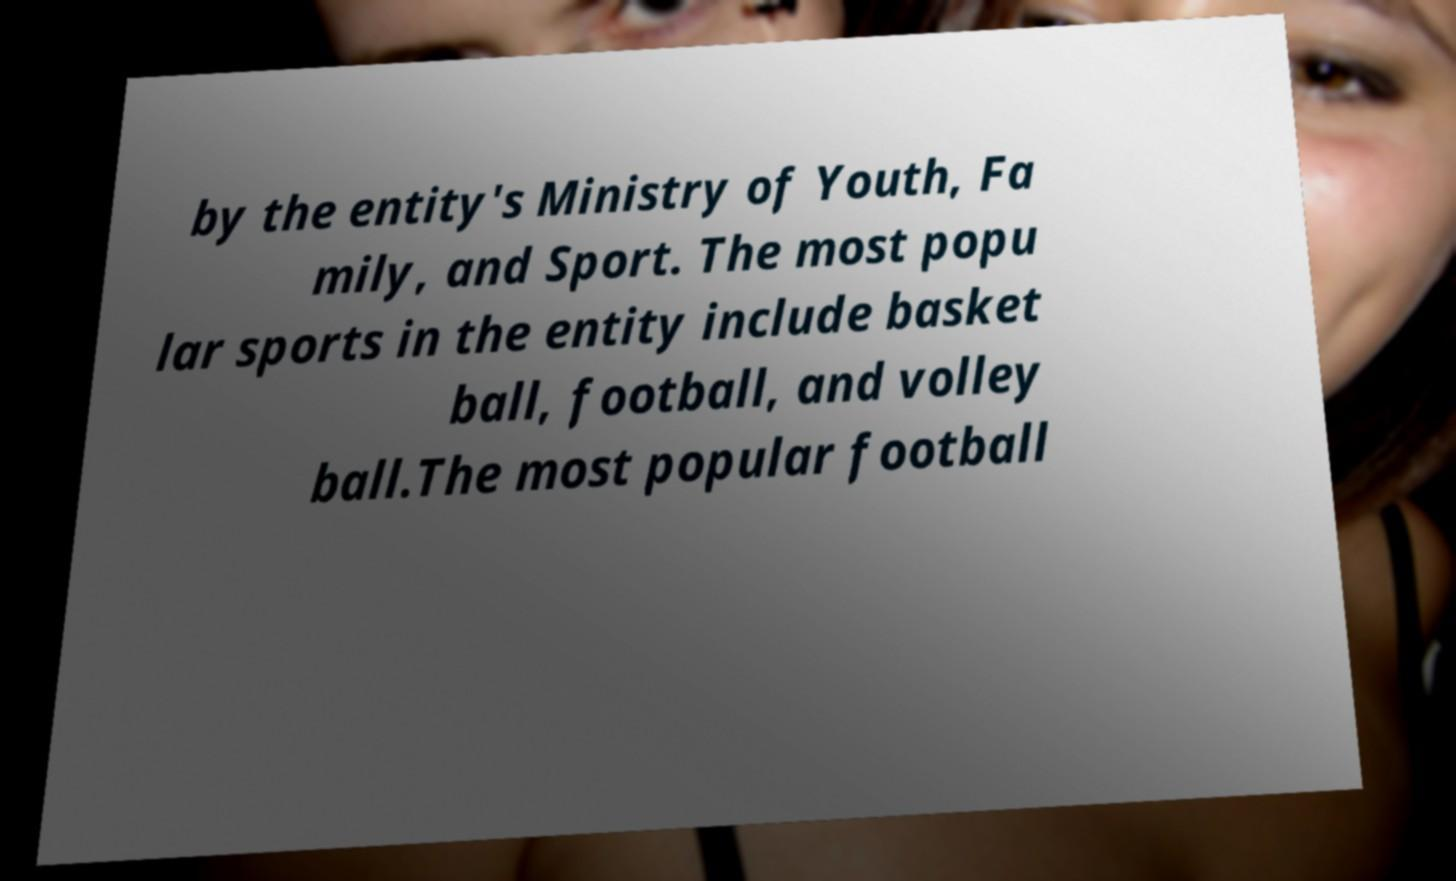For documentation purposes, I need the text within this image transcribed. Could you provide that? by the entity's Ministry of Youth, Fa mily, and Sport. The most popu lar sports in the entity include basket ball, football, and volley ball.The most popular football 